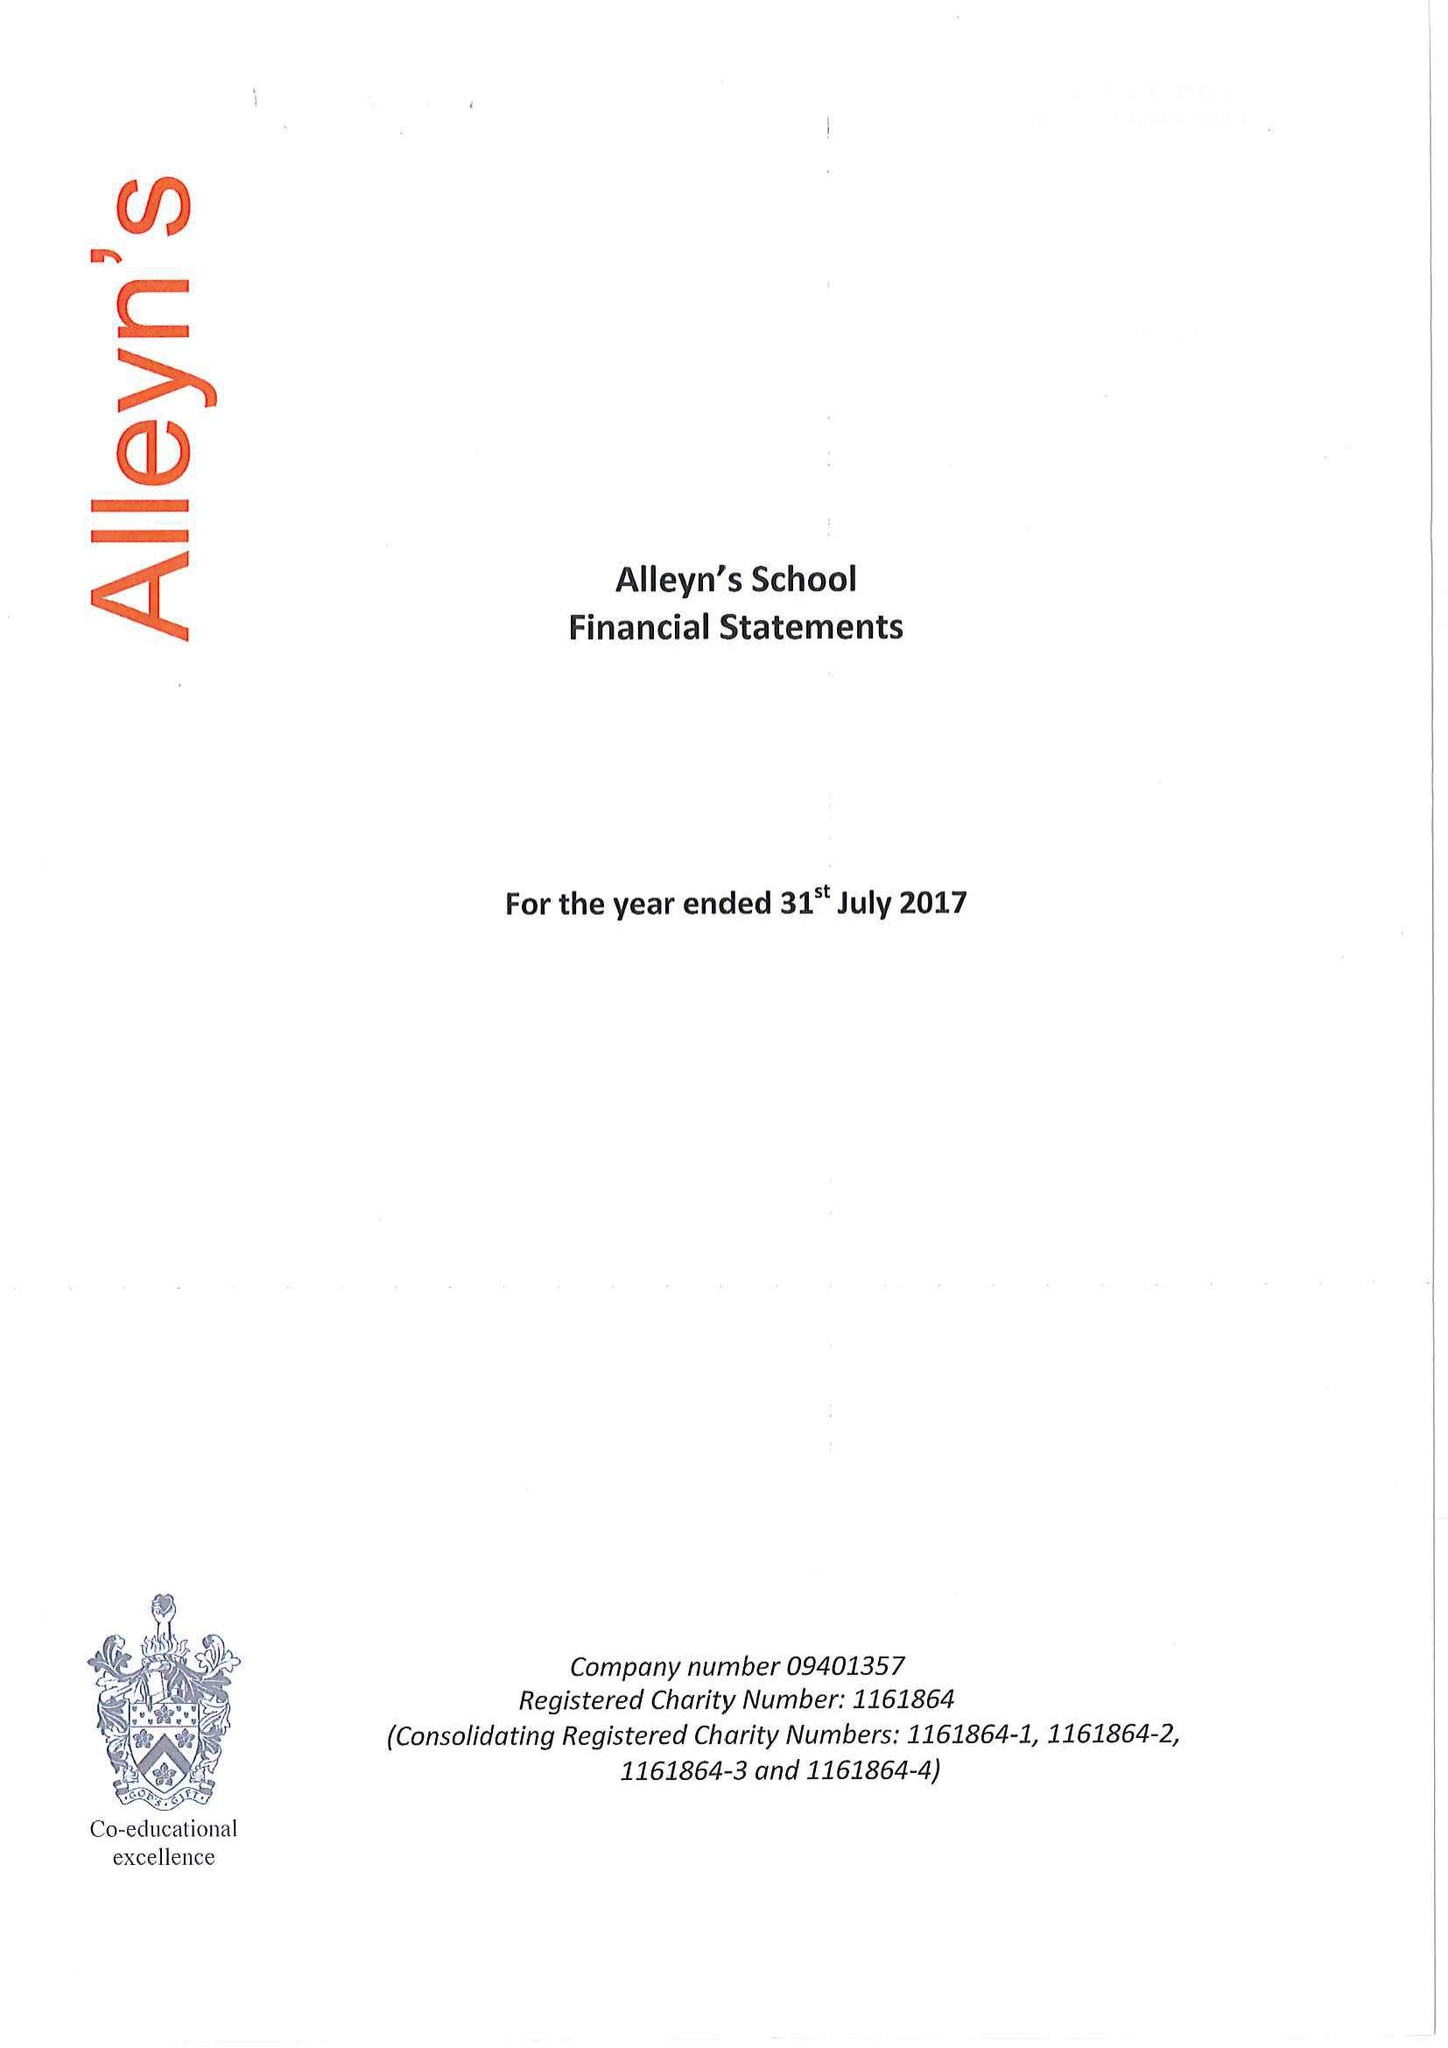What is the value for the address__post_town?
Answer the question using a single word or phrase. LONDON 